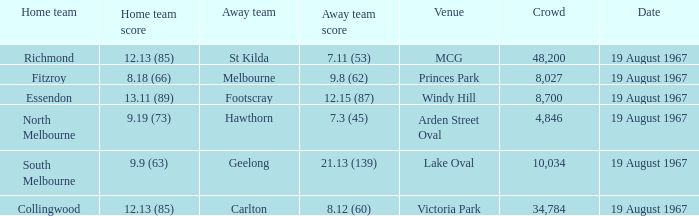What did the home team of essendon score? 13.11 (89). 